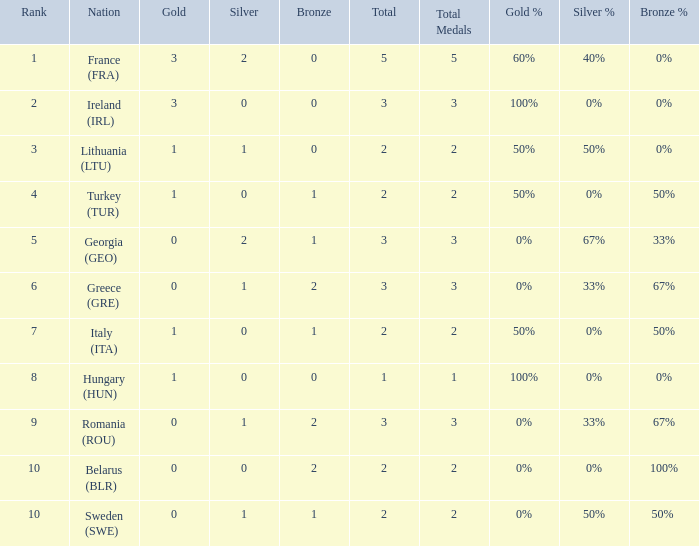What's the rank of Turkey (TUR) with a total more than 2? 0.0. 